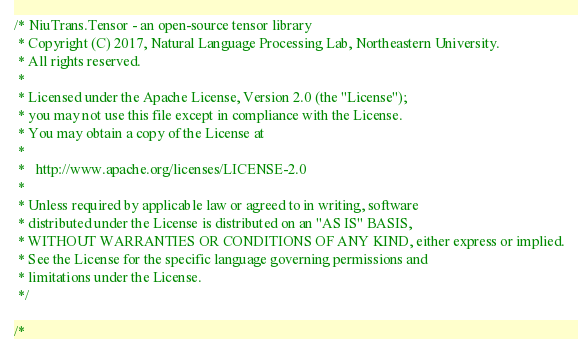Convert code to text. <code><loc_0><loc_0><loc_500><loc_500><_Cuda_>/* NiuTrans.Tensor - an open-source tensor library
 * Copyright (C) 2017, Natural Language Processing Lab, Northeastern University. 
 * All rights reserved.
 *
 * Licensed under the Apache License, Version 2.0 (the "License");
 * you may not use this file except in compliance with the License.
 * You may obtain a copy of the License at
 *
 *   http://www.apache.org/licenses/LICENSE-2.0
 *
 * Unless required by applicable law or agreed to in writing, software
 * distributed under the License is distributed on an "AS IS" BASIS,
 * WITHOUT WARRANTIES OR CONDITIONS OF ANY KIND, either express or implied.
 * See the License for the specific language governing permissions and
 * limitations under the License.
 */

/*</code> 